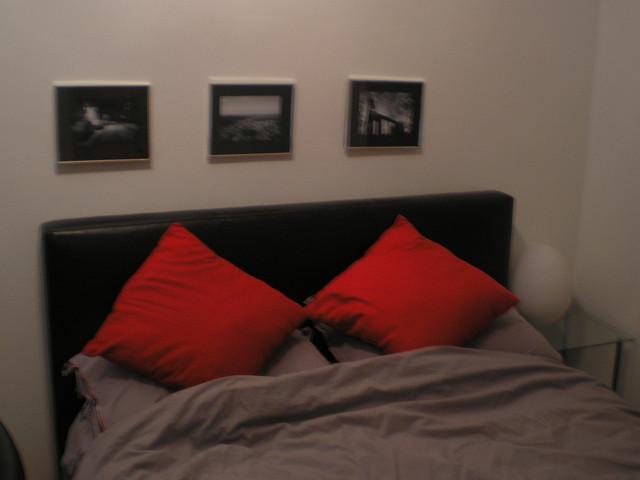How many pictures are on the wall?
Quick response, please. 3. Is there a piece of paper on the pillow?
Quick response, please. No. Would a person wear clothes the color of the pillow?
Quick response, please. Yes. What shape are pillows showing?
Short answer required. Diamond. Is anyone in the bed?
Give a very brief answer. No. What is the headboard made of?
Answer briefly. Leather. 